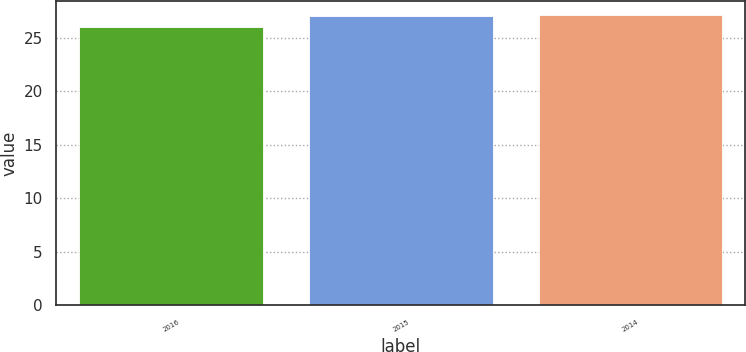Convert chart. <chart><loc_0><loc_0><loc_500><loc_500><bar_chart><fcel>2016<fcel>2015<fcel>2014<nl><fcel>26<fcel>27<fcel>27.1<nl></chart> 